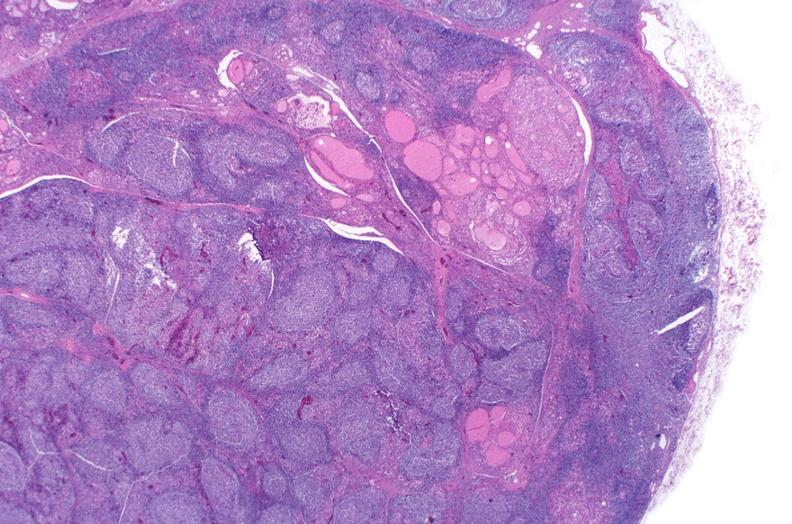what does this image show?
Answer the question using a single word or phrase. Hashimoto 's thyroiditis 